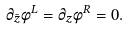<formula> <loc_0><loc_0><loc_500><loc_500>\partial _ { \bar { z } } \phi ^ { L } = \partial _ { z } \phi ^ { R } = 0 .</formula> 